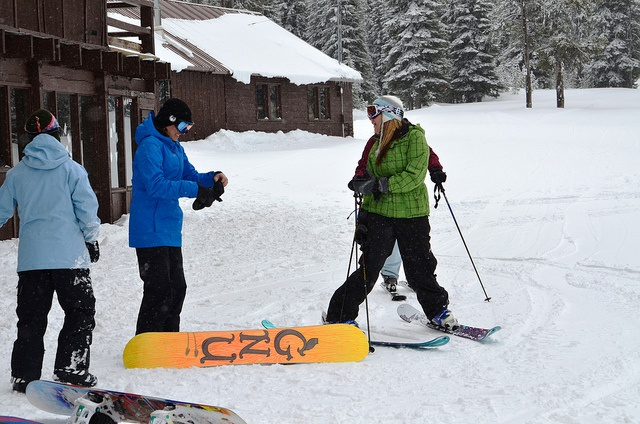Describe the objects in this image and their specific colors. I can see people in black, gray, and darkgray tones, people in black, darkgreen, and gray tones, people in black, blue, darkblue, and navy tones, snowboard in black, orange, and gray tones, and snowboard in black, darkgray, and gray tones in this image. 